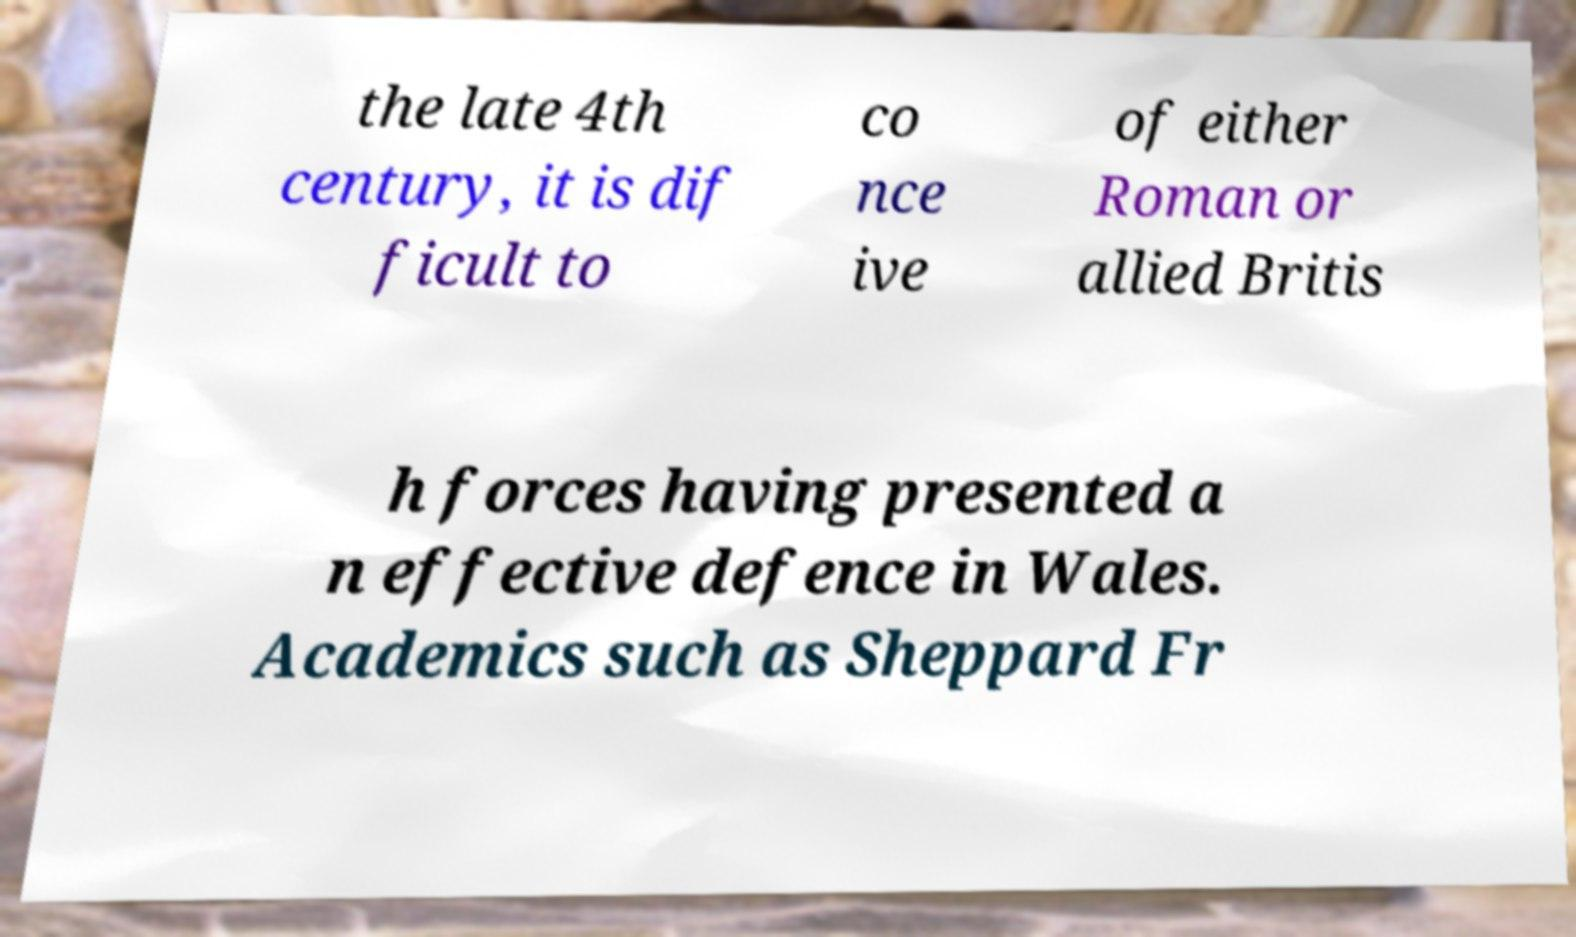Please read and relay the text visible in this image. What does it say? the late 4th century, it is dif ficult to co nce ive of either Roman or allied Britis h forces having presented a n effective defence in Wales. Academics such as Sheppard Fr 